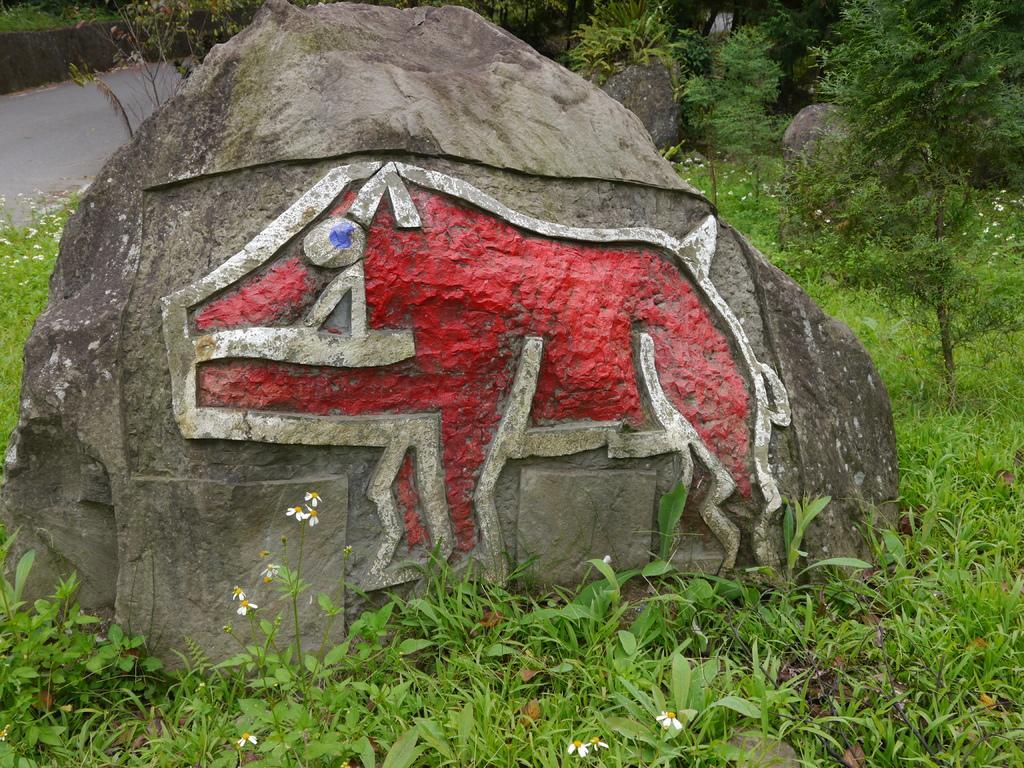Please provide a concise description of this image. In the picture we can see a grass surface on it, we can see a stone with a painting of a pig, which is red in color and besides the stone also we can see some plants and trees. 